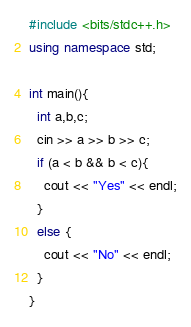Convert code to text. <code><loc_0><loc_0><loc_500><loc_500><_C++_>#include <bits/stdc++.h>
using namespace std;

int main(){
  int a,b,c;
  cin >> a >> b >> c;
  if (a < b && b < c){
    cout << "Yes" << endl;
  }
  else {
    cout << "No" << endl;
  }
}

</code> 